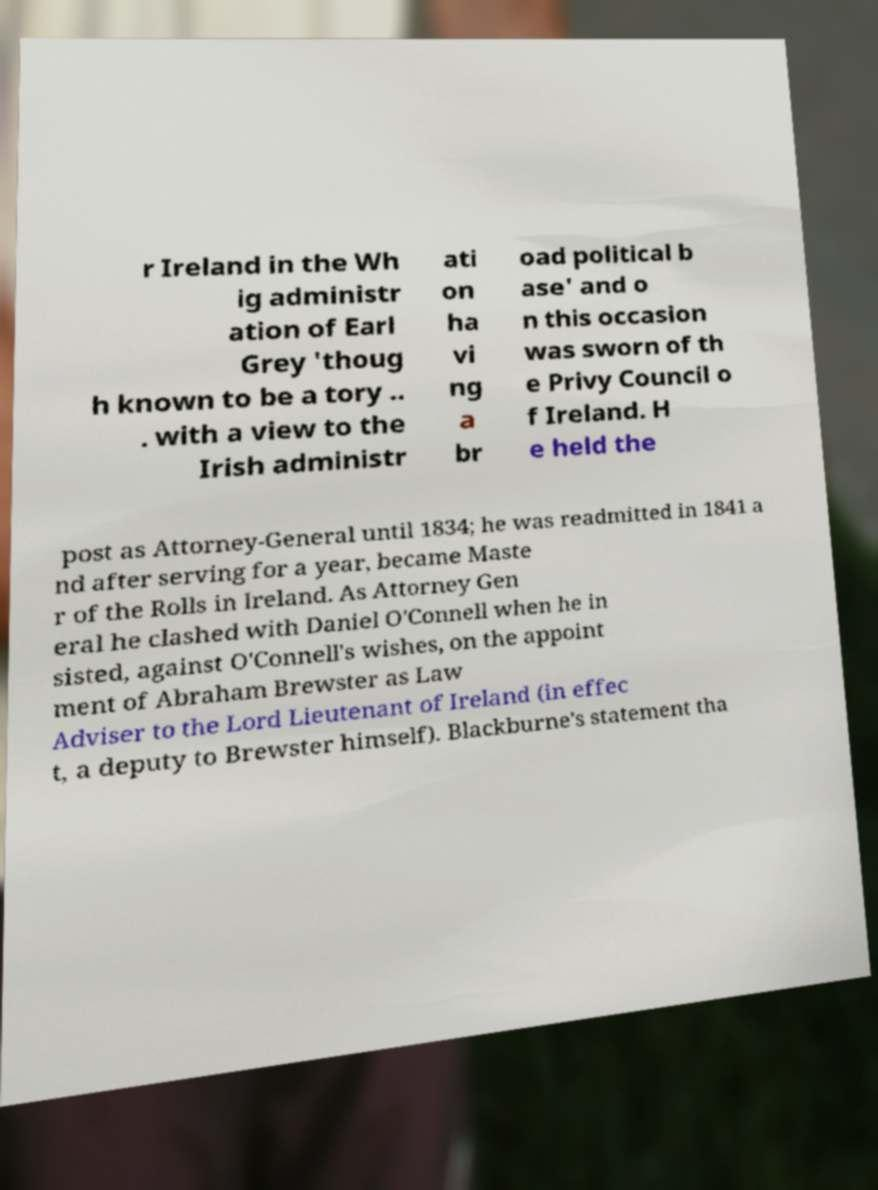Can you read and provide the text displayed in the image?This photo seems to have some interesting text. Can you extract and type it out for me? r Ireland in the Wh ig administr ation of Earl Grey 'thoug h known to be a tory .. . with a view to the Irish administr ati on ha vi ng a br oad political b ase' and o n this occasion was sworn of th e Privy Council o f Ireland. H e held the post as Attorney-General until 1834; he was readmitted in 1841 a nd after serving for a year, became Maste r of the Rolls in Ireland. As Attorney Gen eral he clashed with Daniel O'Connell when he in sisted, against O'Connell's wishes, on the appoint ment of Abraham Brewster as Law Adviser to the Lord Lieutenant of Ireland (in effec t, a deputy to Brewster himself). Blackburne's statement tha 